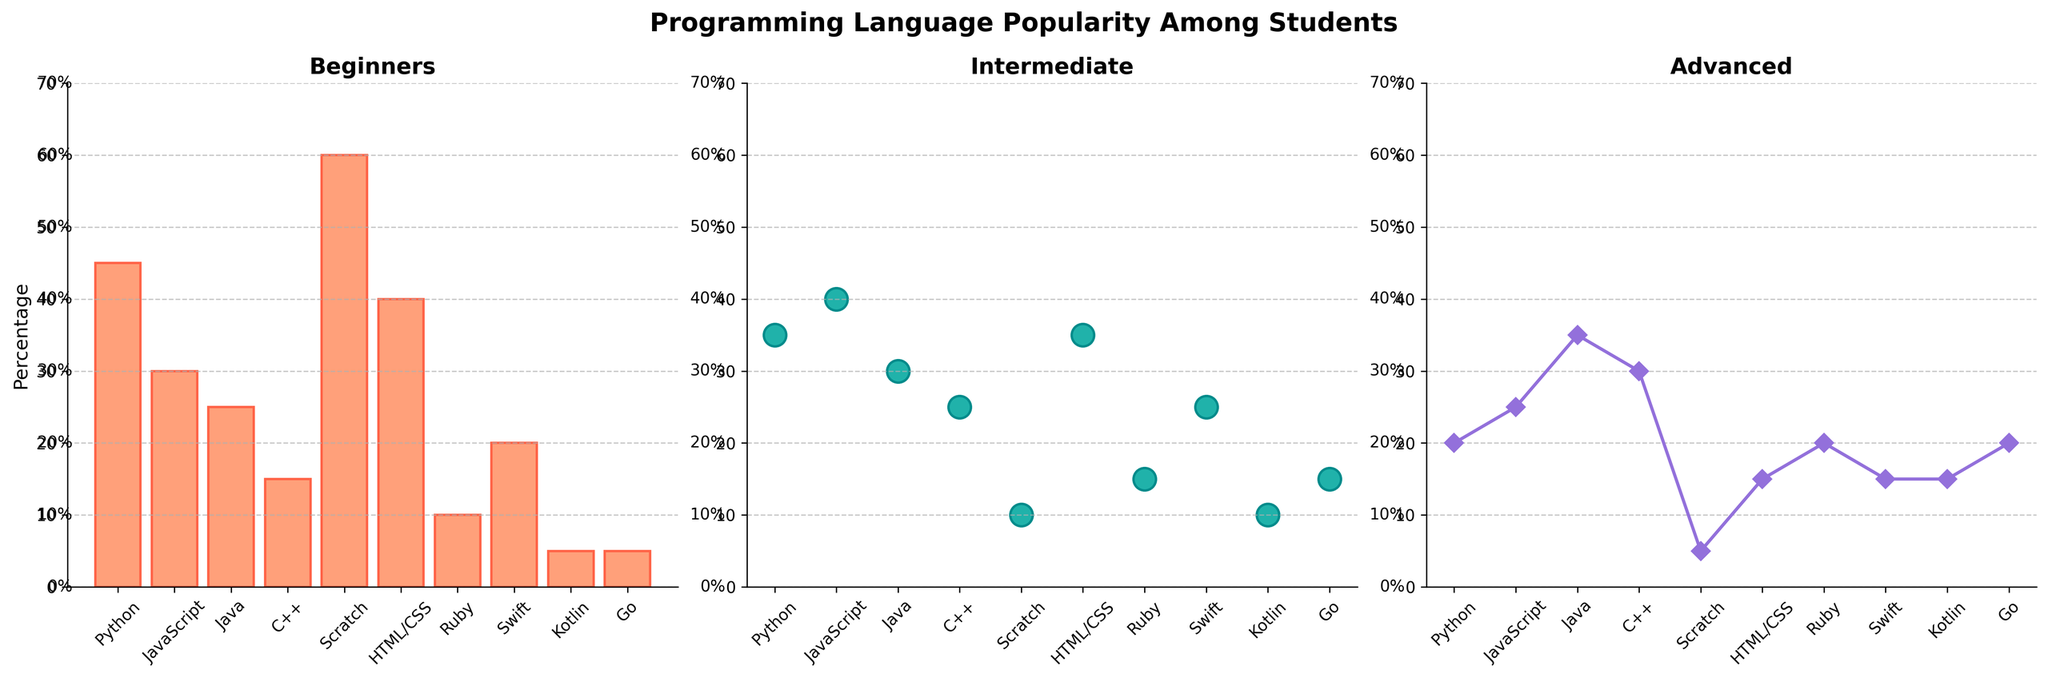Which language is preferred by the most beginners? By observing the heights of the bars in the beginners plot, Scratch has the tallest bar.
Answer: Scratch Which language has the least popularity among intermediate students? Looking at the sizes of the dots in the intermediate plot, Kotlin and Scratch have the smallest dots, but Kotlin is visually smaller.
Answer: Kotlin How many more beginners prefer Python over C++? Subtract the height of the C++ bar from the height of the Python bar in the beginners plot. Python has 45% and C++ has 15%, so 45 - 15 = 30.
Answer: 30 What is the average popularity of intermediate students for JavaScript, HTML/CSS, and Swift? Sum the sizes of the dots for JavaScript, HTML/CSS, and Swift, then divide by 3. JavaScript: 40, HTML/CSS: 35, Swift: 25. (40 + 35 + 25) / 3 = 100 / 3 ≈ 33.33
Answer: 33.33 Which group has the most consistent popularity across all three proficiency levels? To find consistency, compare the visual differences between the bars, scatter points, and line plots within each language. Java seems to maintain a moderate presence in all three categories.
Answer: Java Which language shows the sharpest drop from beginners to advanced learners? Observe the steepness of lines connecting the points in the beginners and advanced plots. Scratch shows the sharpest decline from 60 to 5.
Answer: Scratch Which language has the most similar popularity for intermediate and advanced levels? Compare the dots in the intermediate plot with the points in the advanced line plot. JavaScript has intermediate and advanced values of 40 and 25, respectively.
Answer: JavaScript How does the popularity of Ruby among beginners compare to its popularity among advanced learners? Compare the height of the Ruby bar in the beginners plot to the position of the Ruby point in the advanced line plot. Ruby has 10% for beginners and 20% for advanced.
Answer: Ruby is less popular among beginners than advanced learners What is the total percentage of students at the intermediate and advanced levels for Go? Add the values from the intermediate and advanced plots for Go. Intermediate: 15, Advanced: 20. 15 + 20 = 35.
Answer: 35 Which languages are equally popular among beginners and intermediate learners? Look for bars and dots at the same height in the beginners and intermediate plots. HTML/CSS has beginners at 40% and intermediate at 35%, which is the closest match.
Answer: HTML/CSS is nearly equal 